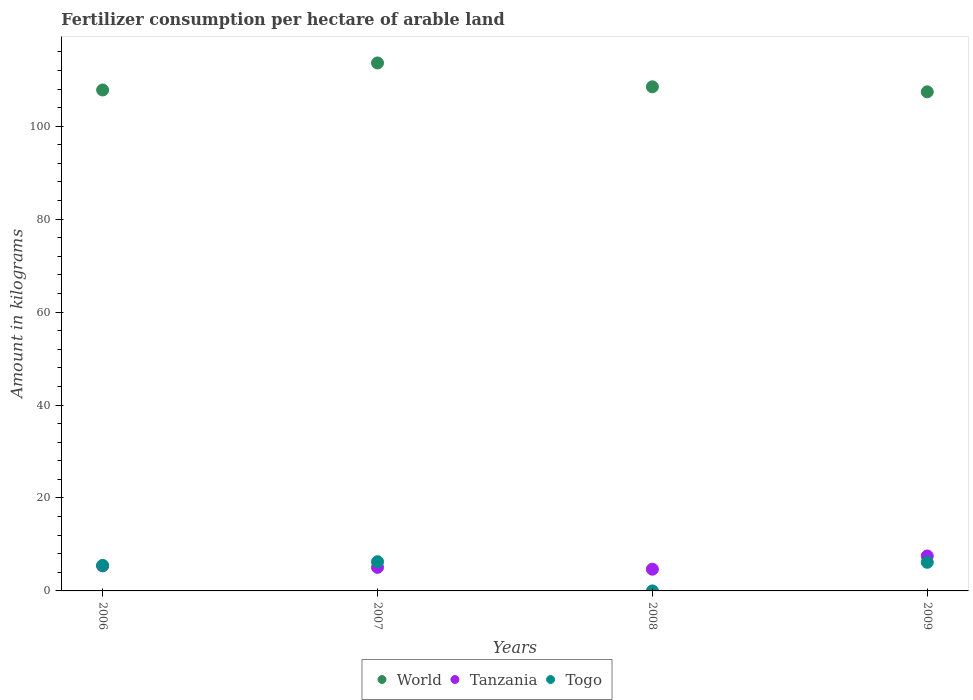How many different coloured dotlines are there?
Offer a terse response. 3. What is the amount of fertilizer consumption in Togo in 2009?
Provide a succinct answer. 6.16. Across all years, what is the maximum amount of fertilizer consumption in World?
Ensure brevity in your answer.  113.61. Across all years, what is the minimum amount of fertilizer consumption in Tanzania?
Your answer should be compact. 4.68. In which year was the amount of fertilizer consumption in Togo maximum?
Provide a short and direct response. 2007. What is the total amount of fertilizer consumption in World in the graph?
Give a very brief answer. 437.28. What is the difference between the amount of fertilizer consumption in World in 2007 and that in 2008?
Make the answer very short. 5.13. What is the difference between the amount of fertilizer consumption in Tanzania in 2006 and the amount of fertilizer consumption in World in 2008?
Offer a very short reply. -103.08. What is the average amount of fertilizer consumption in World per year?
Your answer should be compact. 109.32. In the year 2008, what is the difference between the amount of fertilizer consumption in Togo and amount of fertilizer consumption in Tanzania?
Ensure brevity in your answer.  -4.68. What is the ratio of the amount of fertilizer consumption in Togo in 2007 to that in 2009?
Your answer should be very brief. 1.02. Is the amount of fertilizer consumption in Tanzania in 2006 less than that in 2007?
Your answer should be compact. No. What is the difference between the highest and the second highest amount of fertilizer consumption in Tanzania?
Keep it short and to the point. 2.13. What is the difference between the highest and the lowest amount of fertilizer consumption in Tanzania?
Offer a terse response. 2.85. Is the sum of the amount of fertilizer consumption in World in 2008 and 2009 greater than the maximum amount of fertilizer consumption in Togo across all years?
Give a very brief answer. Yes. Is the amount of fertilizer consumption in Togo strictly less than the amount of fertilizer consumption in Tanzania over the years?
Make the answer very short. No. What is the difference between two consecutive major ticks on the Y-axis?
Make the answer very short. 20. Are the values on the major ticks of Y-axis written in scientific E-notation?
Offer a very short reply. No. Where does the legend appear in the graph?
Offer a terse response. Bottom center. What is the title of the graph?
Provide a succinct answer. Fertilizer consumption per hectare of arable land. Does "Turks and Caicos Islands" appear as one of the legend labels in the graph?
Your answer should be very brief. No. What is the label or title of the Y-axis?
Your answer should be compact. Amount in kilograms. What is the Amount in kilograms in World in 2006?
Give a very brief answer. 107.79. What is the Amount in kilograms of Tanzania in 2006?
Offer a very short reply. 5.4. What is the Amount in kilograms in Togo in 2006?
Your answer should be compact. 5.48. What is the Amount in kilograms in World in 2007?
Your answer should be very brief. 113.61. What is the Amount in kilograms in Tanzania in 2007?
Keep it short and to the point. 5.07. What is the Amount in kilograms in Togo in 2007?
Your answer should be compact. 6.28. What is the Amount in kilograms in World in 2008?
Ensure brevity in your answer.  108.48. What is the Amount in kilograms in Tanzania in 2008?
Offer a very short reply. 4.68. What is the Amount in kilograms of Togo in 2008?
Ensure brevity in your answer.  0. What is the Amount in kilograms of World in 2009?
Offer a terse response. 107.4. What is the Amount in kilograms of Tanzania in 2009?
Offer a very short reply. 7.52. What is the Amount in kilograms of Togo in 2009?
Ensure brevity in your answer.  6.16. Across all years, what is the maximum Amount in kilograms in World?
Give a very brief answer. 113.61. Across all years, what is the maximum Amount in kilograms in Tanzania?
Provide a succinct answer. 7.52. Across all years, what is the maximum Amount in kilograms of Togo?
Make the answer very short. 6.28. Across all years, what is the minimum Amount in kilograms of World?
Your response must be concise. 107.4. Across all years, what is the minimum Amount in kilograms of Tanzania?
Make the answer very short. 4.68. Across all years, what is the minimum Amount in kilograms of Togo?
Your answer should be compact. 0. What is the total Amount in kilograms of World in the graph?
Provide a short and direct response. 437.28. What is the total Amount in kilograms of Tanzania in the graph?
Your response must be concise. 22.67. What is the total Amount in kilograms in Togo in the graph?
Keep it short and to the point. 17.92. What is the difference between the Amount in kilograms in World in 2006 and that in 2007?
Your answer should be very brief. -5.81. What is the difference between the Amount in kilograms in Tanzania in 2006 and that in 2007?
Give a very brief answer. 0.33. What is the difference between the Amount in kilograms of Togo in 2006 and that in 2007?
Your answer should be very brief. -0.8. What is the difference between the Amount in kilograms of World in 2006 and that in 2008?
Offer a very short reply. -0.69. What is the difference between the Amount in kilograms in Tanzania in 2006 and that in 2008?
Provide a short and direct response. 0.72. What is the difference between the Amount in kilograms of Togo in 2006 and that in 2008?
Your answer should be compact. 5.48. What is the difference between the Amount in kilograms of World in 2006 and that in 2009?
Your response must be concise. 0.4. What is the difference between the Amount in kilograms of Tanzania in 2006 and that in 2009?
Your answer should be compact. -2.13. What is the difference between the Amount in kilograms of Togo in 2006 and that in 2009?
Offer a very short reply. -0.68. What is the difference between the Amount in kilograms of World in 2007 and that in 2008?
Your answer should be very brief. 5.13. What is the difference between the Amount in kilograms of Tanzania in 2007 and that in 2008?
Provide a succinct answer. 0.4. What is the difference between the Amount in kilograms of Togo in 2007 and that in 2008?
Offer a very short reply. 6.28. What is the difference between the Amount in kilograms of World in 2007 and that in 2009?
Offer a terse response. 6.21. What is the difference between the Amount in kilograms in Tanzania in 2007 and that in 2009?
Your answer should be compact. -2.45. What is the difference between the Amount in kilograms of Togo in 2007 and that in 2009?
Your response must be concise. 0.12. What is the difference between the Amount in kilograms in World in 2008 and that in 2009?
Ensure brevity in your answer.  1.08. What is the difference between the Amount in kilograms in Tanzania in 2008 and that in 2009?
Your answer should be compact. -2.85. What is the difference between the Amount in kilograms of Togo in 2008 and that in 2009?
Give a very brief answer. -6.16. What is the difference between the Amount in kilograms of World in 2006 and the Amount in kilograms of Tanzania in 2007?
Your response must be concise. 102.72. What is the difference between the Amount in kilograms in World in 2006 and the Amount in kilograms in Togo in 2007?
Provide a short and direct response. 101.51. What is the difference between the Amount in kilograms of Tanzania in 2006 and the Amount in kilograms of Togo in 2007?
Provide a short and direct response. -0.88. What is the difference between the Amount in kilograms in World in 2006 and the Amount in kilograms in Tanzania in 2008?
Provide a succinct answer. 103.12. What is the difference between the Amount in kilograms of World in 2006 and the Amount in kilograms of Togo in 2008?
Give a very brief answer. 107.79. What is the difference between the Amount in kilograms of Tanzania in 2006 and the Amount in kilograms of Togo in 2008?
Keep it short and to the point. 5.4. What is the difference between the Amount in kilograms of World in 2006 and the Amount in kilograms of Tanzania in 2009?
Your response must be concise. 100.27. What is the difference between the Amount in kilograms in World in 2006 and the Amount in kilograms in Togo in 2009?
Your response must be concise. 101.63. What is the difference between the Amount in kilograms in Tanzania in 2006 and the Amount in kilograms in Togo in 2009?
Offer a terse response. -0.76. What is the difference between the Amount in kilograms in World in 2007 and the Amount in kilograms in Tanzania in 2008?
Provide a succinct answer. 108.93. What is the difference between the Amount in kilograms of World in 2007 and the Amount in kilograms of Togo in 2008?
Ensure brevity in your answer.  113.61. What is the difference between the Amount in kilograms of Tanzania in 2007 and the Amount in kilograms of Togo in 2008?
Give a very brief answer. 5.07. What is the difference between the Amount in kilograms in World in 2007 and the Amount in kilograms in Tanzania in 2009?
Your answer should be very brief. 106.08. What is the difference between the Amount in kilograms in World in 2007 and the Amount in kilograms in Togo in 2009?
Give a very brief answer. 107.45. What is the difference between the Amount in kilograms of Tanzania in 2007 and the Amount in kilograms of Togo in 2009?
Your answer should be very brief. -1.09. What is the difference between the Amount in kilograms of World in 2008 and the Amount in kilograms of Tanzania in 2009?
Your answer should be compact. 100.96. What is the difference between the Amount in kilograms of World in 2008 and the Amount in kilograms of Togo in 2009?
Offer a very short reply. 102.32. What is the difference between the Amount in kilograms in Tanzania in 2008 and the Amount in kilograms in Togo in 2009?
Your response must be concise. -1.49. What is the average Amount in kilograms of World per year?
Offer a very short reply. 109.32. What is the average Amount in kilograms of Tanzania per year?
Offer a very short reply. 5.67. What is the average Amount in kilograms of Togo per year?
Your response must be concise. 4.48. In the year 2006, what is the difference between the Amount in kilograms of World and Amount in kilograms of Tanzania?
Keep it short and to the point. 102.4. In the year 2006, what is the difference between the Amount in kilograms in World and Amount in kilograms in Togo?
Your response must be concise. 102.31. In the year 2006, what is the difference between the Amount in kilograms in Tanzania and Amount in kilograms in Togo?
Your answer should be very brief. -0.08. In the year 2007, what is the difference between the Amount in kilograms in World and Amount in kilograms in Tanzania?
Your answer should be compact. 108.54. In the year 2007, what is the difference between the Amount in kilograms of World and Amount in kilograms of Togo?
Your answer should be very brief. 107.33. In the year 2007, what is the difference between the Amount in kilograms in Tanzania and Amount in kilograms in Togo?
Your response must be concise. -1.21. In the year 2008, what is the difference between the Amount in kilograms of World and Amount in kilograms of Tanzania?
Give a very brief answer. 103.8. In the year 2008, what is the difference between the Amount in kilograms of World and Amount in kilograms of Togo?
Ensure brevity in your answer.  108.48. In the year 2008, what is the difference between the Amount in kilograms of Tanzania and Amount in kilograms of Togo?
Your answer should be very brief. 4.68. In the year 2009, what is the difference between the Amount in kilograms in World and Amount in kilograms in Tanzania?
Provide a short and direct response. 99.87. In the year 2009, what is the difference between the Amount in kilograms of World and Amount in kilograms of Togo?
Keep it short and to the point. 101.24. In the year 2009, what is the difference between the Amount in kilograms of Tanzania and Amount in kilograms of Togo?
Provide a short and direct response. 1.36. What is the ratio of the Amount in kilograms in World in 2006 to that in 2007?
Make the answer very short. 0.95. What is the ratio of the Amount in kilograms of Tanzania in 2006 to that in 2007?
Offer a very short reply. 1.06. What is the ratio of the Amount in kilograms of Togo in 2006 to that in 2007?
Offer a terse response. 0.87. What is the ratio of the Amount in kilograms in World in 2006 to that in 2008?
Give a very brief answer. 0.99. What is the ratio of the Amount in kilograms of Tanzania in 2006 to that in 2008?
Your answer should be compact. 1.15. What is the ratio of the Amount in kilograms in Togo in 2006 to that in 2008?
Your answer should be compact. 1.28e+04. What is the ratio of the Amount in kilograms of World in 2006 to that in 2009?
Offer a very short reply. 1. What is the ratio of the Amount in kilograms in Tanzania in 2006 to that in 2009?
Offer a very short reply. 0.72. What is the ratio of the Amount in kilograms in Togo in 2006 to that in 2009?
Make the answer very short. 0.89. What is the ratio of the Amount in kilograms in World in 2007 to that in 2008?
Offer a terse response. 1.05. What is the ratio of the Amount in kilograms in Tanzania in 2007 to that in 2008?
Your response must be concise. 1.08. What is the ratio of the Amount in kilograms of Togo in 2007 to that in 2008?
Offer a terse response. 1.47e+04. What is the ratio of the Amount in kilograms of World in 2007 to that in 2009?
Keep it short and to the point. 1.06. What is the ratio of the Amount in kilograms in Tanzania in 2007 to that in 2009?
Offer a very short reply. 0.67. What is the ratio of the Amount in kilograms of Togo in 2007 to that in 2009?
Your answer should be very brief. 1.02. What is the ratio of the Amount in kilograms in World in 2008 to that in 2009?
Provide a succinct answer. 1.01. What is the ratio of the Amount in kilograms of Tanzania in 2008 to that in 2009?
Give a very brief answer. 0.62. What is the ratio of the Amount in kilograms in Togo in 2008 to that in 2009?
Keep it short and to the point. 0. What is the difference between the highest and the second highest Amount in kilograms of World?
Provide a short and direct response. 5.13. What is the difference between the highest and the second highest Amount in kilograms of Tanzania?
Keep it short and to the point. 2.13. What is the difference between the highest and the second highest Amount in kilograms in Togo?
Your answer should be compact. 0.12. What is the difference between the highest and the lowest Amount in kilograms of World?
Ensure brevity in your answer.  6.21. What is the difference between the highest and the lowest Amount in kilograms of Tanzania?
Your response must be concise. 2.85. What is the difference between the highest and the lowest Amount in kilograms in Togo?
Ensure brevity in your answer.  6.28. 